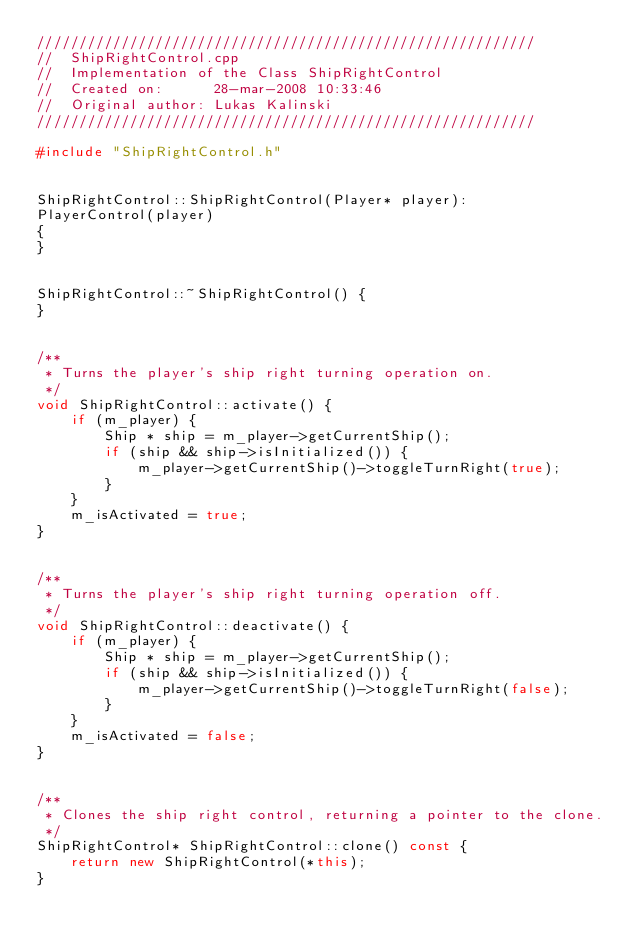<code> <loc_0><loc_0><loc_500><loc_500><_C++_>///////////////////////////////////////////////////////////
//  ShipRightControl.cpp
//  Implementation of the Class ShipRightControl
//  Created on:      28-mar-2008 10:33:46
//  Original author: Lukas Kalinski
///////////////////////////////////////////////////////////

#include "ShipRightControl.h"


ShipRightControl::ShipRightControl(Player* player):
PlayerControl(player)
{
}


ShipRightControl::~ShipRightControl() {
}


/**
 * Turns the player's ship right turning operation on.
 */
void ShipRightControl::activate() {
	if (m_player) {
		Ship * ship = m_player->getCurrentShip();
		if (ship && ship->isInitialized()) {
			m_player->getCurrentShip()->toggleTurnRight(true);
		}
	}
	m_isActivated = true;
}


/**
 * Turns the player's ship right turning operation off.
 */
void ShipRightControl::deactivate() {
	if (m_player) {
		Ship * ship = m_player->getCurrentShip();
		if (ship && ship->isInitialized()) {
			m_player->getCurrentShip()->toggleTurnRight(false);
		}
	}
	m_isActivated = false;
}


/**
 * Clones the ship right control, returning a pointer to the clone.
 */
ShipRightControl* ShipRightControl::clone() const {
	return new ShipRightControl(*this);
}</code> 